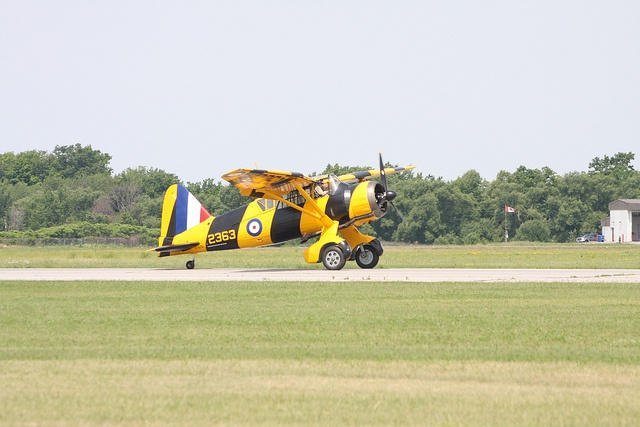Describe the objects in this image and their specific colors. I can see airplane in lavender, gray, orange, gold, and black tones and car in lavender, darkgray, gray, and lightgray tones in this image. 